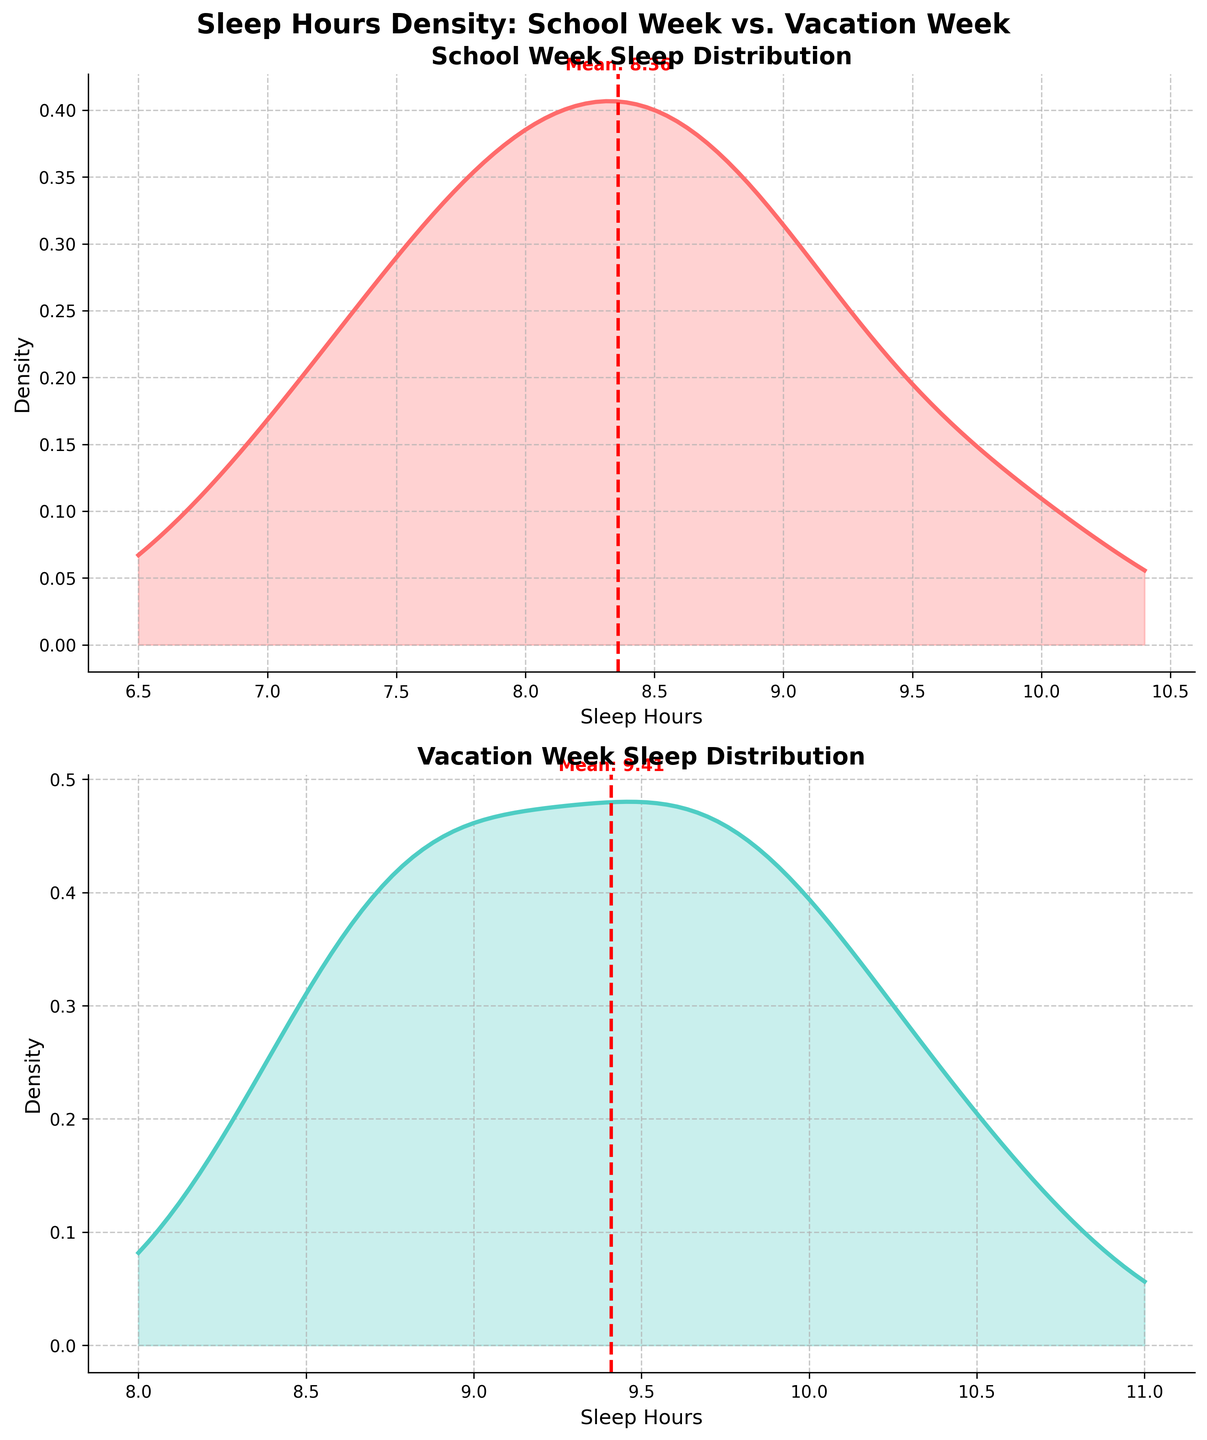What is the main title of the figure? The main title is shown at the top center of the figure.
Answer: Sleep Hours Density: School Week vs. Vacation Week What color represents the School Week sleep distribution? The School Week sleep distribution is depicted using a specific color. Look at the color used in labeled areas and the density plot for School Week.
Answer: Red What is the mean sleep hours during the school week? The mean line is marked on the School Week density plot with a value indicated near it.
Answer: 8.36 Where is the mean sleep hours line for the Vacation Week distribution? The Vacation Week mean line is drawn on the density plot, and its value can be found next to the line.
Answer: 9.41 Which week has a higher peak density value, School Week or Vacation Week? Compare the peaks of the two density plots. The higher peak is determined by the visual height of the density curve.
Answer: School Week What is the average difference in sleep hours between school weeks and vacation weeks? Subtract the mean sleep hour of School Week from that of Vacation Week using the values indicated next to the mean lines: 9.41 - 8.36.
Answer: 1.05 How does the range of sleep hours differ between school weeks and vacation weeks? Compare the x-axis ranges for each density plot and describe how they differ between School Week and Vacation Week.
Answer: Vacation Week has a wider range Which plot has a more spread-out sleep distribution? Determine this by looking at the width and flatness of each density curve: a more spread-out distribution will have a flatter, wider curve.
Answer: Vacation Week Are there any visible outliers in either the school week or vacation week density plots? Check for any sharp peaks or isolated points outside the general range of the data.
Answer: No visible outliers What are the labels for the x-axis and y-axis? Look at the text provided on the axes; these are usually labeled to indicate what each axis measures.
Answer: Sleep Hours, Density 